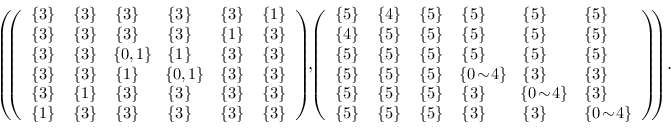Convert formula to latex. <formula><loc_0><loc_0><loc_500><loc_500>\begin{array} { r l } & { \left ( \, \left ( \begin{array} { l l l l l l } { \{ 3 \} } & { \{ 3 \} } & { \{ 3 \} } & { \{ 3 \} } & { \{ 3 \} } & { \{ 1 \} } \\ { \{ 3 \} } & { \{ 3 \} } & { \{ 3 \} } & { \{ 3 \} } & { \{ 1 \} } & { \{ 3 \} } \\ { \{ 3 \} } & { \{ 3 \} } & { \, \{ 0 , 1 \} \, } & { \{ 1 \} } & { \{ 3 \} } & { \{ 3 \} } \\ { \{ 3 \} } & { \{ 3 \} } & { \{ 1 \} } & { \, \{ 0 , 1 \} \, } & { \{ 3 \} } & { \{ 3 \} } \\ { \{ 3 \} } & { \{ 1 \} } & { \{ 3 \} } & { \{ 3 \} } & { \{ 3 \} } & { \{ 3 \} } \\ { \{ 1 \} } & { \{ 3 \} } & { \{ 3 \} } & { \{ 3 \} } & { \{ 3 \} } & { \{ 3 \} } \end{array} \right ) \, , \, \left ( \begin{array} { l l l l l l } { \{ 5 \} } & { \{ 4 \} } & { \{ 5 \} } & { \{ 5 \} } & { \{ 5 \} } & { \{ 5 \} } \\ { \{ 4 \} } & { \{ 5 \} } & { \{ 5 \} } & { \{ 5 \} } & { \{ 5 \} } & { \{ 5 \} } \\ { \{ 5 \} } & { \{ 5 \} } & { \{ 5 \} } & { \{ 5 \} } & { \{ 5 \} } & { \{ 5 \} } \\ { \{ 5 \} } & { \{ 5 \} } & { \{ 5 \} } & { \, \{ 0 \, \sim \, 4 \} \, } & { \{ 3 \} } & { \{ 3 \} } \\ { \{ 5 \} } & { \{ 5 \} } & { \{ 5 \} } & { \{ 3 \} } & { \, \{ 0 \, \sim \, 4 \} \, } & { \{ 3 \} } \\ { \{ 5 \} } & { \{ 5 \} } & { \{ 5 \} } & { \{ 3 \} } & { \{ 3 \} } & { \{ 0 \, \sim \, 4 \} } \end{array} \right ) \, \right ) \, . } \end{array}</formula> 